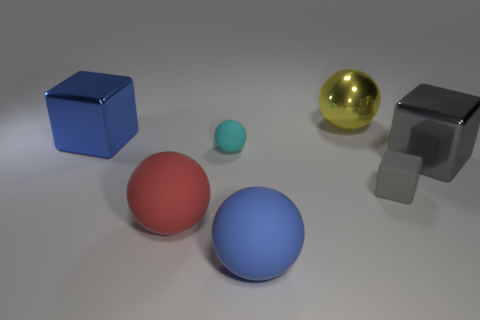Add 2 large green rubber balls. How many objects exist? 9 Subtract all brown balls. Subtract all green cylinders. How many balls are left? 4 Subtract all balls. How many objects are left? 3 Add 6 gray rubber blocks. How many gray rubber blocks exist? 7 Subtract 0 green spheres. How many objects are left? 7 Subtract all tiny cyan matte objects. Subtract all small purple metallic blocks. How many objects are left? 6 Add 6 big blue matte things. How many big blue matte things are left? 7 